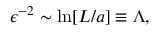Convert formula to latex. <formula><loc_0><loc_0><loc_500><loc_500>\epsilon ^ { - 2 } \sim \ln [ L / a ] \equiv \Lambda ,</formula> 